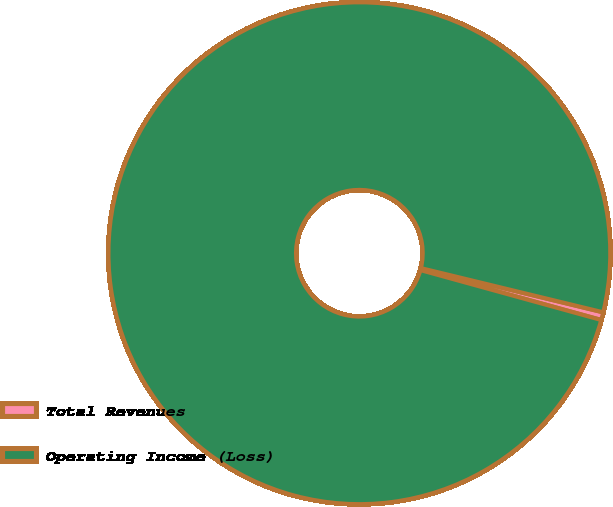Convert chart to OTSL. <chart><loc_0><loc_0><loc_500><loc_500><pie_chart><fcel>Total Revenues<fcel>Operating Income (Loss)<nl><fcel>0.5%<fcel>99.5%<nl></chart> 